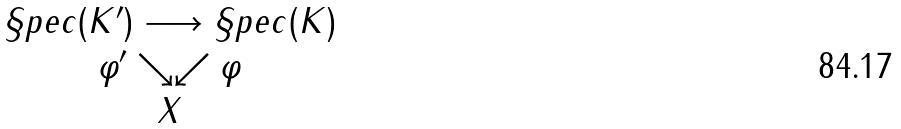<formula> <loc_0><loc_0><loc_500><loc_500>\begin{array} { c } \S p e c ( K ^ { \prime } ) \longrightarrow \S p e c ( K ) \\ \varphi ^ { \prime } \searrow \swarrow \varphi \\ X \end{array}</formula> 